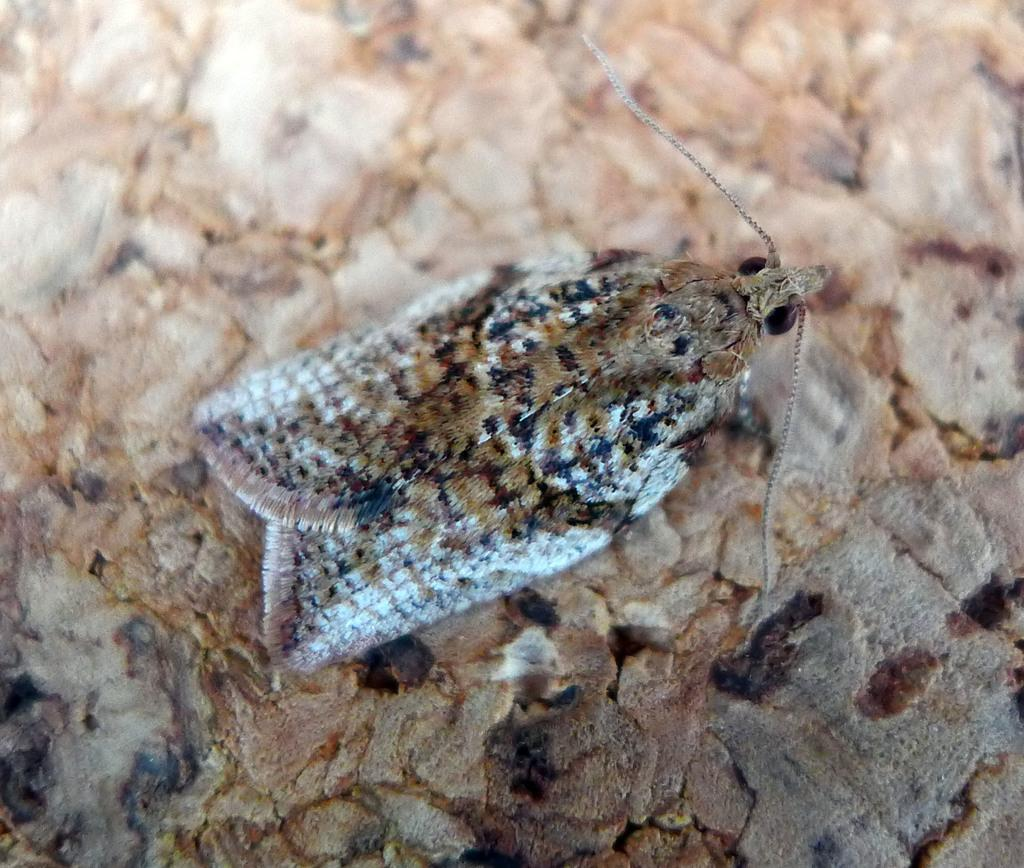What type of creature can be seen in the image? There is an insect present in the image. Where is the insect located on the surface? The insect is on the surface in the middle of the image. How does the insect breathe underwater in the image? The insect does not appear to be underwater in the image, and insects typically do not breathe underwater. 